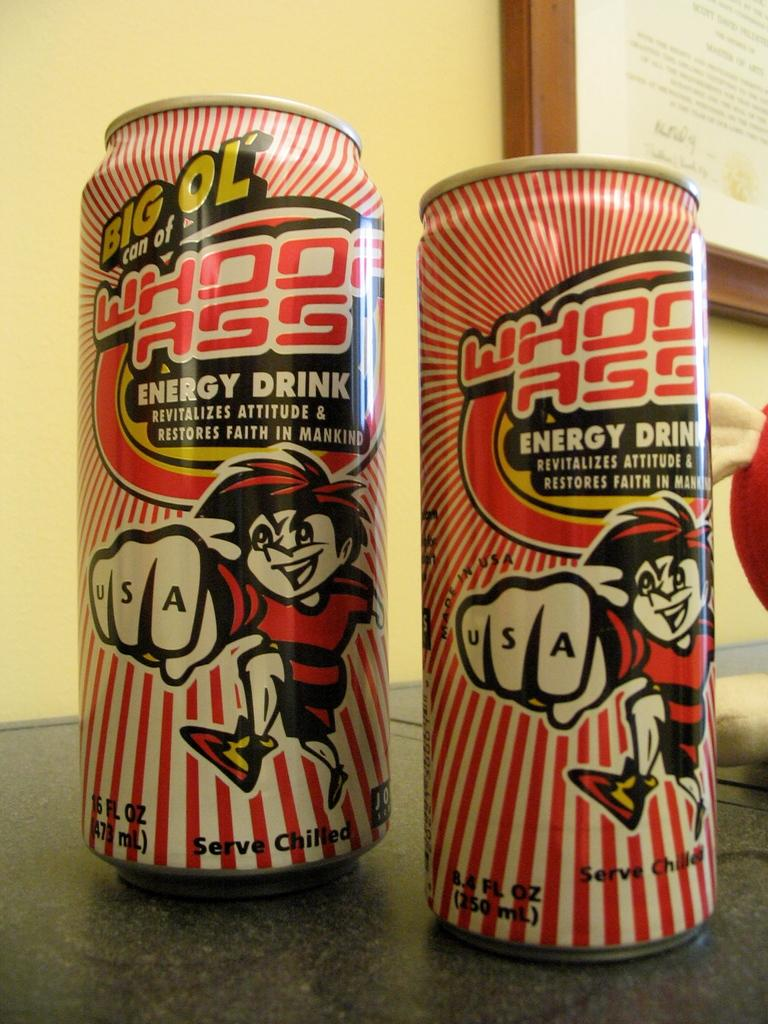<image>
Share a concise interpretation of the image provided. Two cans of energy drink sit on a counter. 